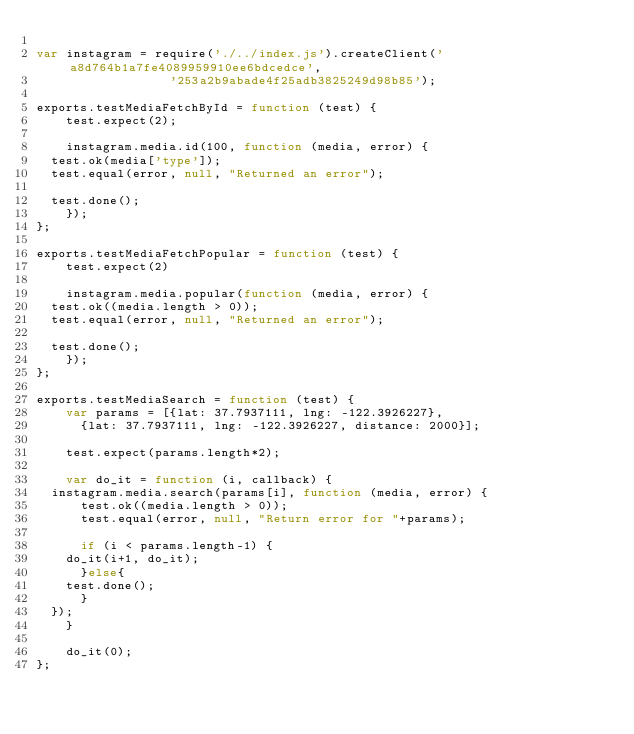<code> <loc_0><loc_0><loc_500><loc_500><_JavaScript_>
var instagram = require('./../index.js').createClient('a8d764b1a7fe4089959910ee6bdcedce',
						      '253a2b9abade4f25adb3825249d98b85');

exports.testMediaFetchById = function (test) {
    test.expect(2);

    instagram.media.id(100, function (media, error) {
	test.ok(media['type']);
	test.equal(error, null, "Returned an error");

	test.done();
    });
};

exports.testMediaFetchPopular = function (test) {
    test.expect(2)

    instagram.media.popular(function (media, error) {
	test.ok((media.length > 0));
	test.equal(error, null, "Returned an error");

	test.done();
    });
};

exports.testMediaSearch = function (test) {
    var params = [{lat: 37.7937111, lng: -122.3926227},
		  {lat: 37.7937111, lng: -122.3926227, distance: 2000}];

    test.expect(params.length*2);
    
    var do_it = function (i, callback) {
	instagram.media.search(params[i], function (media, error) {
	    test.ok((media.length > 0));
	    test.equal(error, null, "Return error for "+params);
	    
	    if (i < params.length-1) {
		do_it(i+1, do_it);
	    }else{
		test.done();
	    }
	});
    }

    do_it(0);
};
</code> 